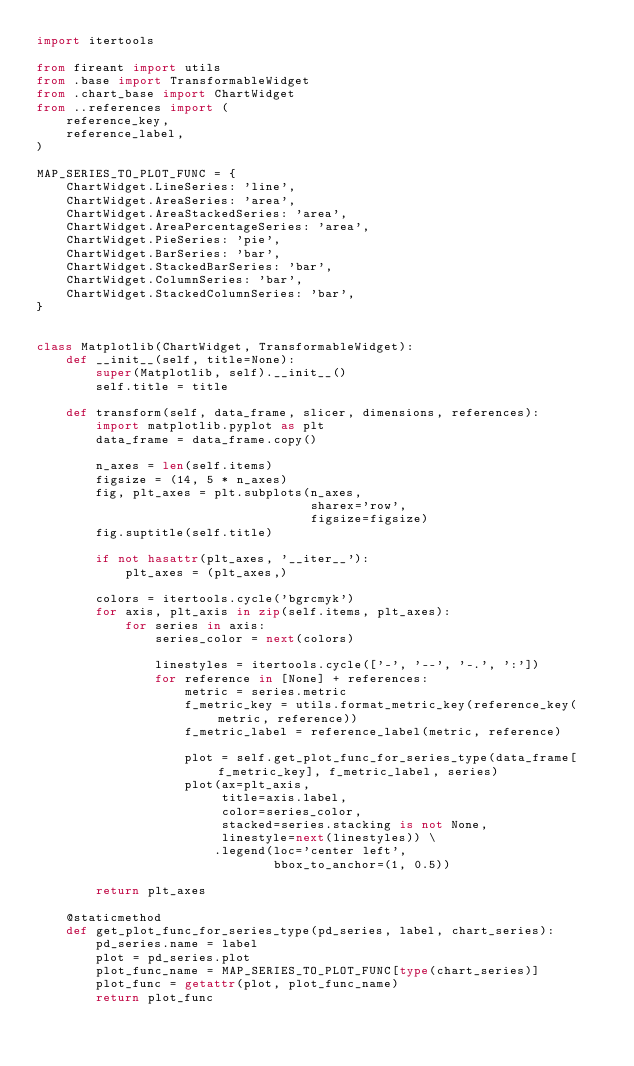<code> <loc_0><loc_0><loc_500><loc_500><_Python_>import itertools

from fireant import utils
from .base import TransformableWidget
from .chart_base import ChartWidget
from ..references import (
    reference_key,
    reference_label,
)

MAP_SERIES_TO_PLOT_FUNC = {
    ChartWidget.LineSeries: 'line',
    ChartWidget.AreaSeries: 'area',
    ChartWidget.AreaStackedSeries: 'area',
    ChartWidget.AreaPercentageSeries: 'area',
    ChartWidget.PieSeries: 'pie',
    ChartWidget.BarSeries: 'bar',
    ChartWidget.StackedBarSeries: 'bar',
    ChartWidget.ColumnSeries: 'bar',
    ChartWidget.StackedColumnSeries: 'bar',
}


class Matplotlib(ChartWidget, TransformableWidget):
    def __init__(self, title=None):
        super(Matplotlib, self).__init__()
        self.title = title

    def transform(self, data_frame, slicer, dimensions, references):
        import matplotlib.pyplot as plt
        data_frame = data_frame.copy()

        n_axes = len(self.items)
        figsize = (14, 5 * n_axes)
        fig, plt_axes = plt.subplots(n_axes,
                                     sharex='row',
                                     figsize=figsize)
        fig.suptitle(self.title)

        if not hasattr(plt_axes, '__iter__'):
            plt_axes = (plt_axes,)

        colors = itertools.cycle('bgrcmyk')
        for axis, plt_axis in zip(self.items, plt_axes):
            for series in axis:
                series_color = next(colors)

                linestyles = itertools.cycle(['-', '--', '-.', ':'])
                for reference in [None] + references:
                    metric = series.metric
                    f_metric_key = utils.format_metric_key(reference_key(metric, reference))
                    f_metric_label = reference_label(metric, reference)

                    plot = self.get_plot_func_for_series_type(data_frame[f_metric_key], f_metric_label, series)
                    plot(ax=plt_axis,
                         title=axis.label,
                         color=series_color,
                         stacked=series.stacking is not None,
                         linestyle=next(linestyles)) \
                        .legend(loc='center left',
                                bbox_to_anchor=(1, 0.5))

        return plt_axes

    @staticmethod
    def get_plot_func_for_series_type(pd_series, label, chart_series):
        pd_series.name = label
        plot = pd_series.plot
        plot_func_name = MAP_SERIES_TO_PLOT_FUNC[type(chart_series)]
        plot_func = getattr(plot, plot_func_name)
        return plot_func
</code> 